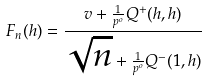Convert formula to latex. <formula><loc_0><loc_0><loc_500><loc_500>F _ { n } ( h ) = \frac { v + \frac { 1 } { p ^ { o } } Q ^ { + } ( h , h ) } { \sqrt { n } + \frac { 1 } { p ^ { o } } Q ^ { - } ( 1 , h ) }</formula> 